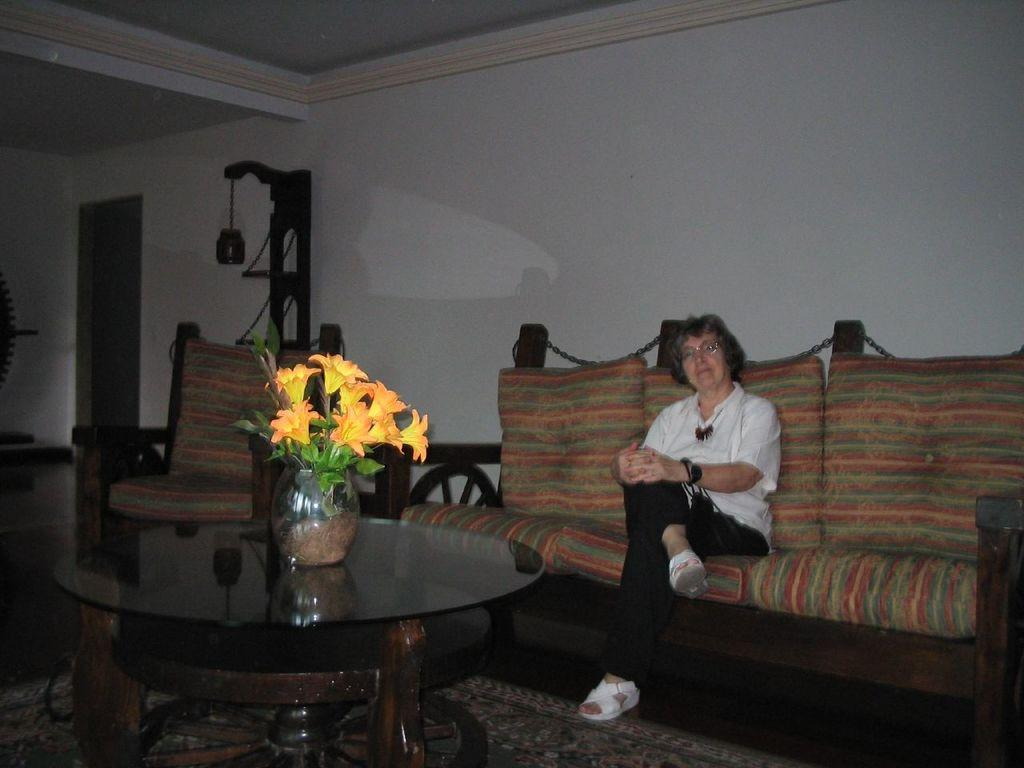What is the woman doing in the image? The woman is sitting on a sofa in the image. What can be seen on the table in the image? There is a flower vase on a table in the image. What is visible in the background of the image? There is a wall and a chair visible in the background of the image. What type of sound does the jellyfish make in the image? There is no jellyfish present in the image, so it cannot make any sound. 